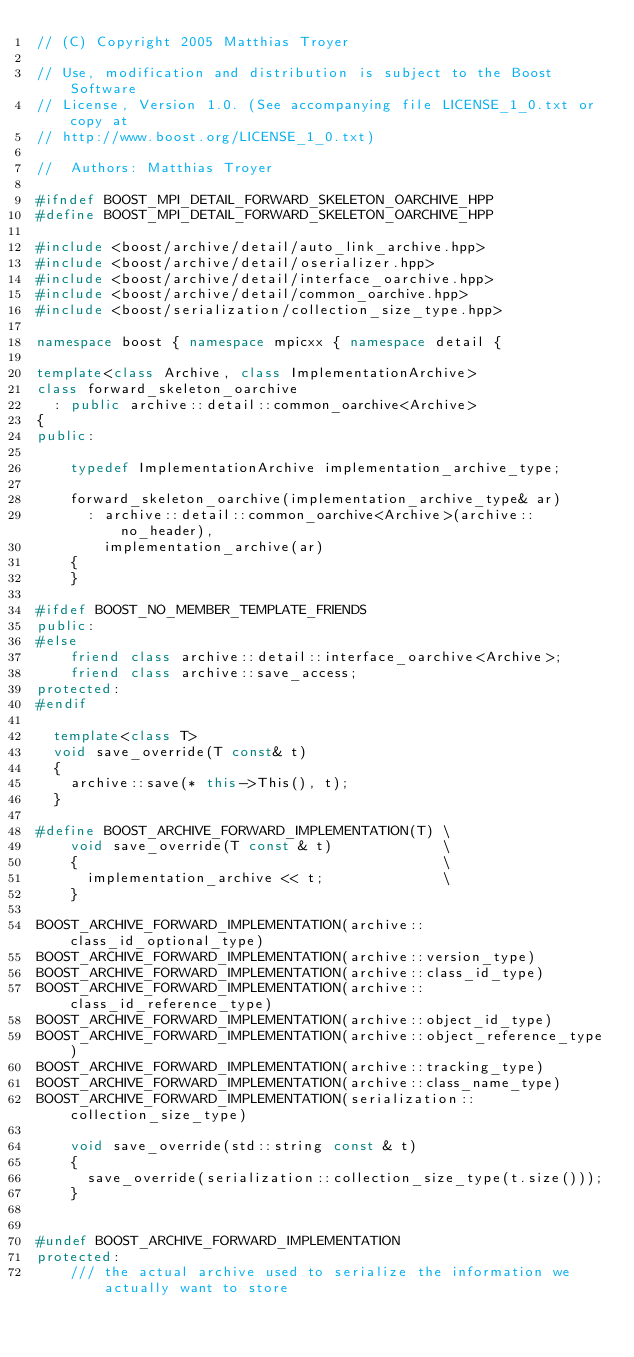<code> <loc_0><loc_0><loc_500><loc_500><_C++_>// (C) Copyright 2005 Matthias Troyer 

// Use, modification and distribution is subject to the Boost Software
// License, Version 1.0. (See accompanying file LICENSE_1_0.txt or copy at
// http://www.boost.org/LICENSE_1_0.txt)

//  Authors: Matthias Troyer

#ifndef BOOST_MPI_DETAIL_FORWARD_SKELETON_OARCHIVE_HPP
#define BOOST_MPI_DETAIL_FORWARD_SKELETON_OARCHIVE_HPP

#include <boost/archive/detail/auto_link_archive.hpp>
#include <boost/archive/detail/oserializer.hpp>
#include <boost/archive/detail/interface_oarchive.hpp>
#include <boost/archive/detail/common_oarchive.hpp>
#include <boost/serialization/collection_size_type.hpp>

namespace boost { namespace mpicxx { namespace detail {

template<class Archive, class ImplementationArchive>
class forward_skeleton_oarchive 
  : public archive::detail::common_oarchive<Archive>
{
public:

    typedef ImplementationArchive implementation_archive_type;

    forward_skeleton_oarchive(implementation_archive_type& ar) 
      : archive::detail::common_oarchive<Archive>(archive::no_header),
        implementation_archive(ar)
    {
    }

#ifdef BOOST_NO_MEMBER_TEMPLATE_FRIENDS
public:
#else
    friend class archive::detail::interface_oarchive<Archive>;
    friend class archive::save_access;
protected:
#endif

  template<class T>
  void save_override(T const& t)
  {
    archive::save(* this->This(), t);
  }

#define BOOST_ARCHIVE_FORWARD_IMPLEMENTATION(T) \
    void save_override(T const & t)             \
    {                                           \
      implementation_archive << t;              \
    }

BOOST_ARCHIVE_FORWARD_IMPLEMENTATION(archive::class_id_optional_type)
BOOST_ARCHIVE_FORWARD_IMPLEMENTATION(archive::version_type)
BOOST_ARCHIVE_FORWARD_IMPLEMENTATION(archive::class_id_type)
BOOST_ARCHIVE_FORWARD_IMPLEMENTATION(archive::class_id_reference_type)
BOOST_ARCHIVE_FORWARD_IMPLEMENTATION(archive::object_id_type)
BOOST_ARCHIVE_FORWARD_IMPLEMENTATION(archive::object_reference_type)
BOOST_ARCHIVE_FORWARD_IMPLEMENTATION(archive::tracking_type)
BOOST_ARCHIVE_FORWARD_IMPLEMENTATION(archive::class_name_type)
BOOST_ARCHIVE_FORWARD_IMPLEMENTATION(serialization::collection_size_type)

    void save_override(std::string const & t)    
    {                                          
      save_override(serialization::collection_size_type(t.size()));       
    }


#undef BOOST_ARCHIVE_FORWARD_IMPLEMENTATION
protected:
    /// the actual archive used to serialize the information we actually want to store</code> 